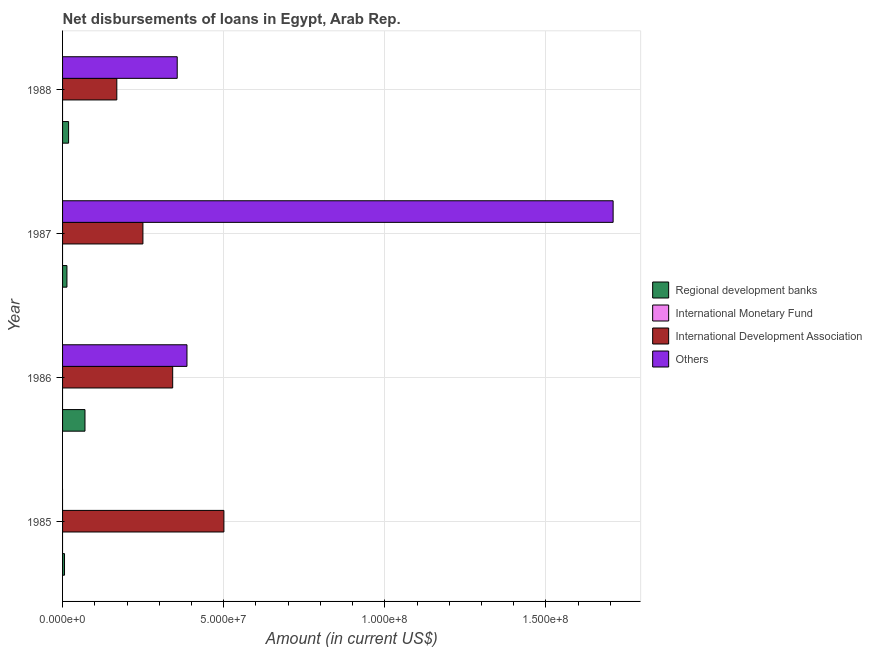How many different coloured bars are there?
Offer a terse response. 3. In how many cases, is the number of bars for a given year not equal to the number of legend labels?
Your response must be concise. 4. What is the amount of loan disimbursed by international development association in 1987?
Your response must be concise. 2.49e+07. Across all years, what is the maximum amount of loan disimbursed by international development association?
Provide a succinct answer. 5.01e+07. Across all years, what is the minimum amount of loan disimbursed by international development association?
Offer a terse response. 1.68e+07. What is the difference between the amount of loan disimbursed by regional development banks in 1987 and that in 1988?
Offer a terse response. -5.12e+05. What is the difference between the amount of loan disimbursed by regional development banks in 1986 and the amount of loan disimbursed by international development association in 1987?
Offer a very short reply. -1.80e+07. What is the average amount of loan disimbursed by international development association per year?
Ensure brevity in your answer.  3.15e+07. In the year 1988, what is the difference between the amount of loan disimbursed by international development association and amount of loan disimbursed by regional development banks?
Your answer should be very brief. 1.50e+07. What is the ratio of the amount of loan disimbursed by regional development banks in 1985 to that in 1987?
Provide a succinct answer. 0.45. What is the difference between the highest and the second highest amount of loan disimbursed by regional development banks?
Your answer should be very brief. 5.09e+06. What is the difference between the highest and the lowest amount of loan disimbursed by international development association?
Make the answer very short. 3.32e+07. Is the sum of the amount of loan disimbursed by international development association in 1985 and 1988 greater than the maximum amount of loan disimbursed by international monetary fund across all years?
Provide a short and direct response. Yes. How many bars are there?
Give a very brief answer. 11. What is the difference between two consecutive major ticks on the X-axis?
Provide a succinct answer. 5.00e+07. Are the values on the major ticks of X-axis written in scientific E-notation?
Ensure brevity in your answer.  Yes. Does the graph contain any zero values?
Your answer should be compact. Yes. Does the graph contain grids?
Offer a very short reply. Yes. How many legend labels are there?
Your response must be concise. 4. What is the title of the graph?
Ensure brevity in your answer.  Net disbursements of loans in Egypt, Arab Rep. What is the Amount (in current US$) of Regional development banks in 1985?
Provide a short and direct response. 6.06e+05. What is the Amount (in current US$) in International Development Association in 1985?
Make the answer very short. 5.01e+07. What is the Amount (in current US$) in Regional development banks in 1986?
Your answer should be compact. 6.96e+06. What is the Amount (in current US$) in International Development Association in 1986?
Give a very brief answer. 3.42e+07. What is the Amount (in current US$) of Others in 1986?
Your answer should be very brief. 3.86e+07. What is the Amount (in current US$) in Regional development banks in 1987?
Your answer should be compact. 1.36e+06. What is the Amount (in current US$) of International Development Association in 1987?
Ensure brevity in your answer.  2.49e+07. What is the Amount (in current US$) of Others in 1987?
Offer a terse response. 1.71e+08. What is the Amount (in current US$) of Regional development banks in 1988?
Offer a very short reply. 1.87e+06. What is the Amount (in current US$) of International Development Association in 1988?
Keep it short and to the point. 1.68e+07. What is the Amount (in current US$) of Others in 1988?
Provide a succinct answer. 3.56e+07. Across all years, what is the maximum Amount (in current US$) in Regional development banks?
Your answer should be compact. 6.96e+06. Across all years, what is the maximum Amount (in current US$) in International Development Association?
Make the answer very short. 5.01e+07. Across all years, what is the maximum Amount (in current US$) of Others?
Make the answer very short. 1.71e+08. Across all years, what is the minimum Amount (in current US$) of Regional development banks?
Provide a short and direct response. 6.06e+05. Across all years, what is the minimum Amount (in current US$) of International Development Association?
Give a very brief answer. 1.68e+07. Across all years, what is the minimum Amount (in current US$) of Others?
Keep it short and to the point. 0. What is the total Amount (in current US$) in Regional development banks in the graph?
Ensure brevity in your answer.  1.08e+07. What is the total Amount (in current US$) of International Development Association in the graph?
Provide a succinct answer. 1.26e+08. What is the total Amount (in current US$) of Others in the graph?
Provide a short and direct response. 2.45e+08. What is the difference between the Amount (in current US$) in Regional development banks in 1985 and that in 1986?
Your answer should be very brief. -6.35e+06. What is the difference between the Amount (in current US$) in International Development Association in 1985 and that in 1986?
Offer a very short reply. 1.59e+07. What is the difference between the Amount (in current US$) in Regional development banks in 1985 and that in 1987?
Keep it short and to the point. -7.50e+05. What is the difference between the Amount (in current US$) of International Development Association in 1985 and that in 1987?
Your answer should be compact. 2.51e+07. What is the difference between the Amount (in current US$) of Regional development banks in 1985 and that in 1988?
Offer a very short reply. -1.26e+06. What is the difference between the Amount (in current US$) in International Development Association in 1985 and that in 1988?
Your answer should be very brief. 3.32e+07. What is the difference between the Amount (in current US$) of Regional development banks in 1986 and that in 1987?
Make the answer very short. 5.60e+06. What is the difference between the Amount (in current US$) of International Development Association in 1986 and that in 1987?
Offer a terse response. 9.23e+06. What is the difference between the Amount (in current US$) in Others in 1986 and that in 1987?
Your response must be concise. -1.32e+08. What is the difference between the Amount (in current US$) in Regional development banks in 1986 and that in 1988?
Your response must be concise. 5.09e+06. What is the difference between the Amount (in current US$) in International Development Association in 1986 and that in 1988?
Offer a terse response. 1.73e+07. What is the difference between the Amount (in current US$) in Others in 1986 and that in 1988?
Provide a succinct answer. 3.03e+06. What is the difference between the Amount (in current US$) in Regional development banks in 1987 and that in 1988?
Offer a very short reply. -5.12e+05. What is the difference between the Amount (in current US$) of International Development Association in 1987 and that in 1988?
Provide a short and direct response. 8.10e+06. What is the difference between the Amount (in current US$) in Others in 1987 and that in 1988?
Ensure brevity in your answer.  1.35e+08. What is the difference between the Amount (in current US$) in Regional development banks in 1985 and the Amount (in current US$) in International Development Association in 1986?
Give a very brief answer. -3.36e+07. What is the difference between the Amount (in current US$) of Regional development banks in 1985 and the Amount (in current US$) of Others in 1986?
Ensure brevity in your answer.  -3.80e+07. What is the difference between the Amount (in current US$) in International Development Association in 1985 and the Amount (in current US$) in Others in 1986?
Your answer should be very brief. 1.15e+07. What is the difference between the Amount (in current US$) in Regional development banks in 1985 and the Amount (in current US$) in International Development Association in 1987?
Ensure brevity in your answer.  -2.43e+07. What is the difference between the Amount (in current US$) in Regional development banks in 1985 and the Amount (in current US$) in Others in 1987?
Make the answer very short. -1.70e+08. What is the difference between the Amount (in current US$) in International Development Association in 1985 and the Amount (in current US$) in Others in 1987?
Ensure brevity in your answer.  -1.21e+08. What is the difference between the Amount (in current US$) in Regional development banks in 1985 and the Amount (in current US$) in International Development Association in 1988?
Keep it short and to the point. -1.62e+07. What is the difference between the Amount (in current US$) of Regional development banks in 1985 and the Amount (in current US$) of Others in 1988?
Your response must be concise. -3.50e+07. What is the difference between the Amount (in current US$) of International Development Association in 1985 and the Amount (in current US$) of Others in 1988?
Provide a succinct answer. 1.45e+07. What is the difference between the Amount (in current US$) of Regional development banks in 1986 and the Amount (in current US$) of International Development Association in 1987?
Your answer should be compact. -1.80e+07. What is the difference between the Amount (in current US$) in Regional development banks in 1986 and the Amount (in current US$) in Others in 1987?
Your response must be concise. -1.64e+08. What is the difference between the Amount (in current US$) in International Development Association in 1986 and the Amount (in current US$) in Others in 1987?
Provide a succinct answer. -1.37e+08. What is the difference between the Amount (in current US$) in Regional development banks in 1986 and the Amount (in current US$) in International Development Association in 1988?
Ensure brevity in your answer.  -9.87e+06. What is the difference between the Amount (in current US$) of Regional development banks in 1986 and the Amount (in current US$) of Others in 1988?
Give a very brief answer. -2.86e+07. What is the difference between the Amount (in current US$) of International Development Association in 1986 and the Amount (in current US$) of Others in 1988?
Provide a short and direct response. -1.41e+06. What is the difference between the Amount (in current US$) in Regional development banks in 1987 and the Amount (in current US$) in International Development Association in 1988?
Offer a very short reply. -1.55e+07. What is the difference between the Amount (in current US$) of Regional development banks in 1987 and the Amount (in current US$) of Others in 1988?
Your answer should be very brief. -3.42e+07. What is the difference between the Amount (in current US$) in International Development Association in 1987 and the Amount (in current US$) in Others in 1988?
Your response must be concise. -1.06e+07. What is the average Amount (in current US$) of Regional development banks per year?
Keep it short and to the point. 2.70e+06. What is the average Amount (in current US$) of International Development Association per year?
Make the answer very short. 3.15e+07. What is the average Amount (in current US$) of Others per year?
Offer a very short reply. 6.13e+07. In the year 1985, what is the difference between the Amount (in current US$) of Regional development banks and Amount (in current US$) of International Development Association?
Your response must be concise. -4.95e+07. In the year 1986, what is the difference between the Amount (in current US$) of Regional development banks and Amount (in current US$) of International Development Association?
Your response must be concise. -2.72e+07. In the year 1986, what is the difference between the Amount (in current US$) in Regional development banks and Amount (in current US$) in Others?
Give a very brief answer. -3.16e+07. In the year 1986, what is the difference between the Amount (in current US$) in International Development Association and Amount (in current US$) in Others?
Make the answer very short. -4.43e+06. In the year 1987, what is the difference between the Amount (in current US$) of Regional development banks and Amount (in current US$) of International Development Association?
Provide a short and direct response. -2.36e+07. In the year 1987, what is the difference between the Amount (in current US$) of Regional development banks and Amount (in current US$) of Others?
Give a very brief answer. -1.69e+08. In the year 1987, what is the difference between the Amount (in current US$) in International Development Association and Amount (in current US$) in Others?
Provide a short and direct response. -1.46e+08. In the year 1988, what is the difference between the Amount (in current US$) in Regional development banks and Amount (in current US$) in International Development Association?
Keep it short and to the point. -1.50e+07. In the year 1988, what is the difference between the Amount (in current US$) in Regional development banks and Amount (in current US$) in Others?
Your response must be concise. -3.37e+07. In the year 1988, what is the difference between the Amount (in current US$) of International Development Association and Amount (in current US$) of Others?
Provide a succinct answer. -1.87e+07. What is the ratio of the Amount (in current US$) of Regional development banks in 1985 to that in 1986?
Offer a very short reply. 0.09. What is the ratio of the Amount (in current US$) in International Development Association in 1985 to that in 1986?
Your answer should be very brief. 1.47. What is the ratio of the Amount (in current US$) in Regional development banks in 1985 to that in 1987?
Your answer should be very brief. 0.45. What is the ratio of the Amount (in current US$) of International Development Association in 1985 to that in 1987?
Give a very brief answer. 2.01. What is the ratio of the Amount (in current US$) in Regional development banks in 1985 to that in 1988?
Provide a short and direct response. 0.32. What is the ratio of the Amount (in current US$) of International Development Association in 1985 to that in 1988?
Keep it short and to the point. 2.97. What is the ratio of the Amount (in current US$) of Regional development banks in 1986 to that in 1987?
Provide a short and direct response. 5.13. What is the ratio of the Amount (in current US$) in International Development Association in 1986 to that in 1987?
Your response must be concise. 1.37. What is the ratio of the Amount (in current US$) of Others in 1986 to that in 1987?
Provide a short and direct response. 0.23. What is the ratio of the Amount (in current US$) of Regional development banks in 1986 to that in 1988?
Provide a succinct answer. 3.72. What is the ratio of the Amount (in current US$) in International Development Association in 1986 to that in 1988?
Offer a terse response. 2.03. What is the ratio of the Amount (in current US$) of Others in 1986 to that in 1988?
Provide a succinct answer. 1.09. What is the ratio of the Amount (in current US$) in Regional development banks in 1987 to that in 1988?
Give a very brief answer. 0.73. What is the ratio of the Amount (in current US$) of International Development Association in 1987 to that in 1988?
Keep it short and to the point. 1.48. What is the ratio of the Amount (in current US$) of Others in 1987 to that in 1988?
Your response must be concise. 4.8. What is the difference between the highest and the second highest Amount (in current US$) of Regional development banks?
Offer a terse response. 5.09e+06. What is the difference between the highest and the second highest Amount (in current US$) of International Development Association?
Your answer should be compact. 1.59e+07. What is the difference between the highest and the second highest Amount (in current US$) of Others?
Offer a terse response. 1.32e+08. What is the difference between the highest and the lowest Amount (in current US$) of Regional development banks?
Offer a terse response. 6.35e+06. What is the difference between the highest and the lowest Amount (in current US$) in International Development Association?
Your answer should be compact. 3.32e+07. What is the difference between the highest and the lowest Amount (in current US$) in Others?
Offer a very short reply. 1.71e+08. 